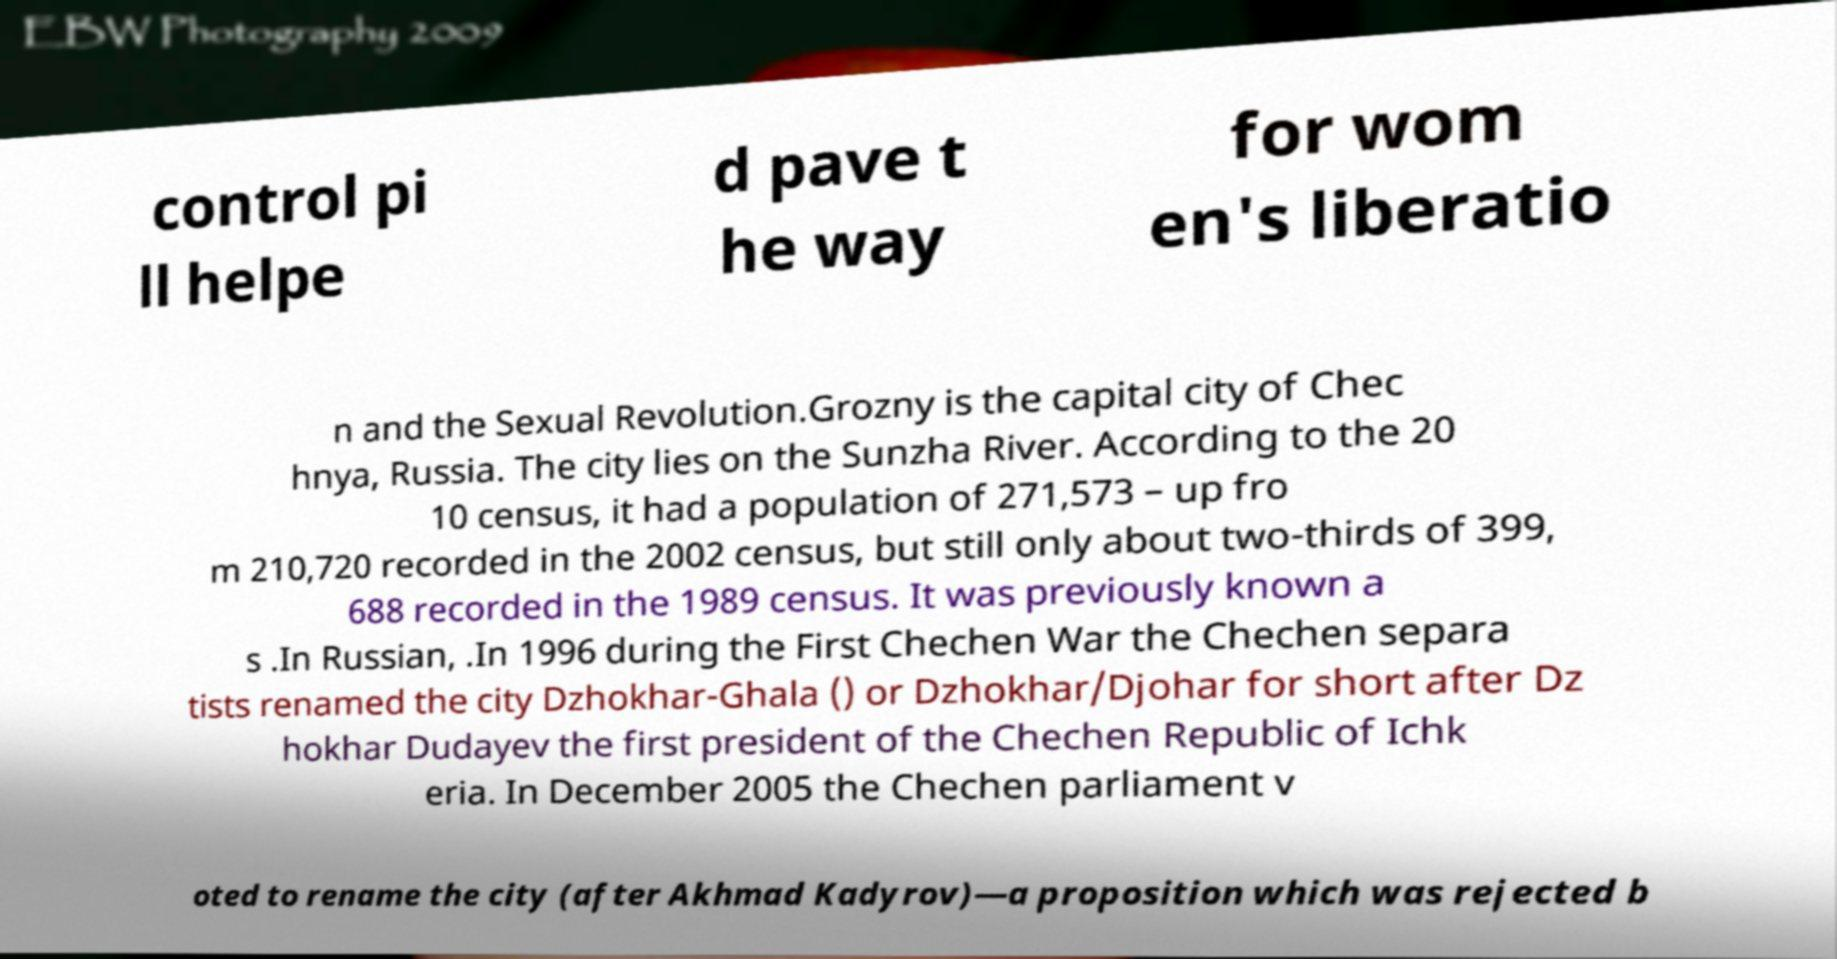For documentation purposes, I need the text within this image transcribed. Could you provide that? control pi ll helpe d pave t he way for wom en's liberatio n and the Sexual Revolution.Grozny is the capital city of Chec hnya, Russia. The city lies on the Sunzha River. According to the 20 10 census, it had a population of 271,573 – up fro m 210,720 recorded in the 2002 census, but still only about two-thirds of 399, 688 recorded in the 1989 census. It was previously known a s .In Russian, .In 1996 during the First Chechen War the Chechen separa tists renamed the city Dzhokhar-Ghala () or Dzhokhar/Djohar for short after Dz hokhar Dudayev the first president of the Chechen Republic of Ichk eria. In December 2005 the Chechen parliament v oted to rename the city (after Akhmad Kadyrov)—a proposition which was rejected b 